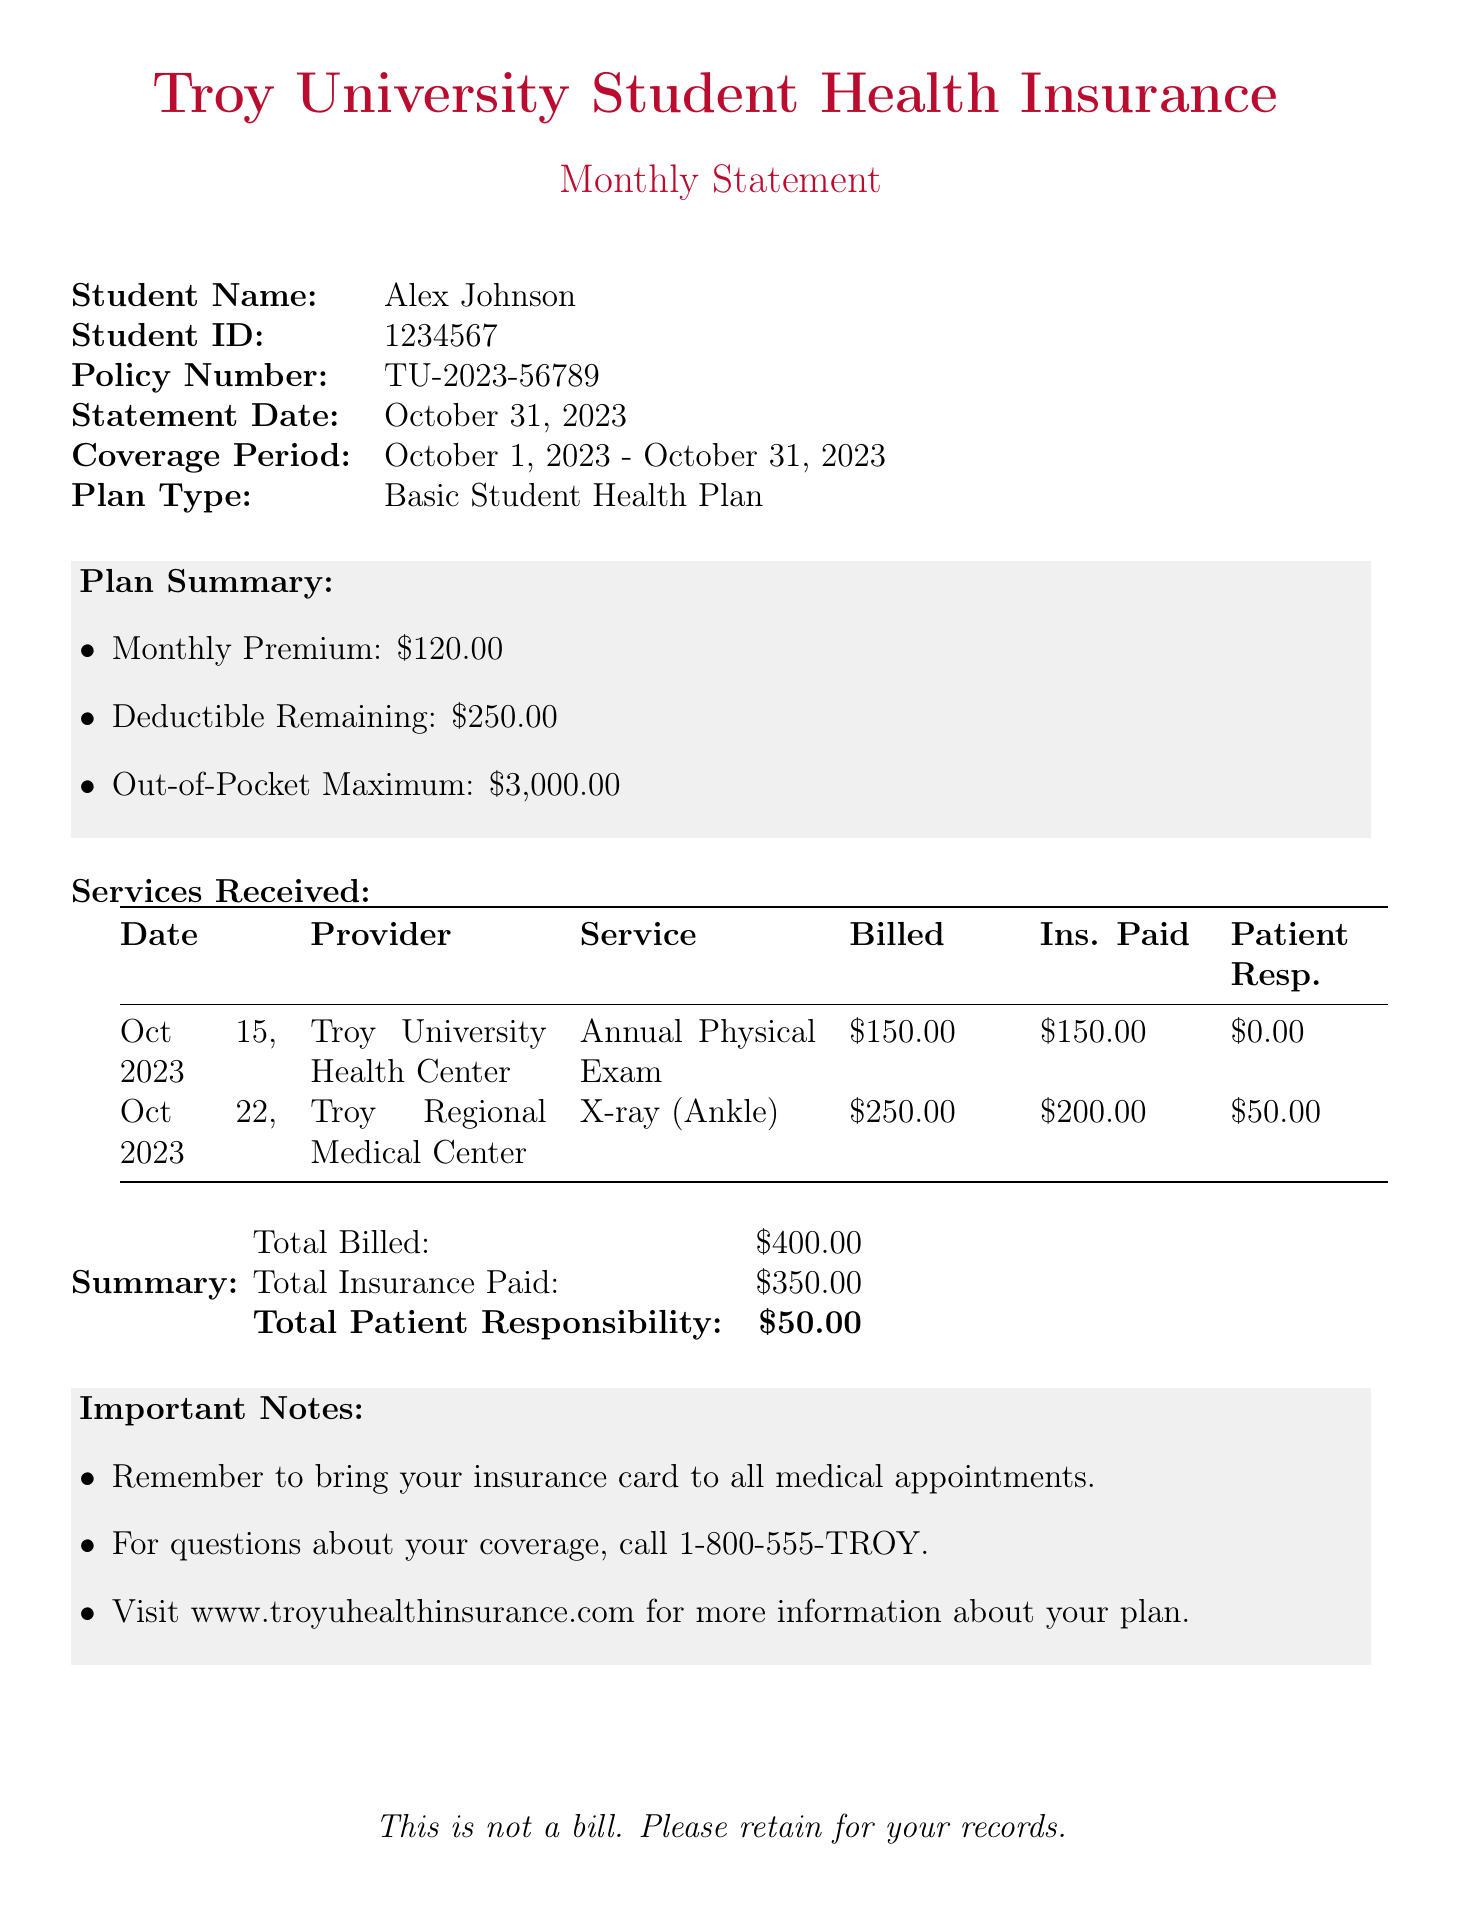What is the student's name? The student's name is listed at the top of the document under "Student Name."
Answer: Alex Johnson What is the policy number? The policy number can be found in the document under "Policy Number."
Answer: TU-2023-56789 What is the statement date? The statement date appears under the "Statement Date" section in the document.
Answer: October 31, 2023 What is the amount of the monthly premium? The monthly premium is mentioned in the "Plan Summary" section of the document.
Answer: $120.00 What is the total patient responsibility? The total patient responsibility is indicated in the "Summary" section at the bottom of the document.
Answer: $50.00 How much did insurance pay for the X-ray? The amount paid by insurance for the X-ray can be found in the "Services Received" table under "Ins. Paid."
Answer: $200.00 What is the coverage period for this statement? The coverage period is specified in the document under "Coverage Period."
Answer: October 1, 2023 - October 31, 2023 What should you remember to bring to medical appointments? An important note in the document advises this item.
Answer: Insurance card What is the out-of-pocket maximum? The out-of-pocket maximum is part of the "Plan Summary" section.
Answer: $3,000.00 